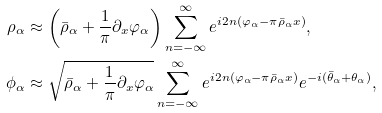<formula> <loc_0><loc_0><loc_500><loc_500>\rho _ { \alpha } & \approx \left ( \bar { \rho } _ { \alpha } + \frac { 1 } { \pi } \partial _ { x } \varphi _ { \alpha } \right ) \sum _ { n = - \infty } ^ { \infty } e ^ { i 2 n ( \varphi _ { \alpha } - \pi \bar { \rho } _ { \alpha } x ) } , \\ \phi _ { \alpha } & \approx \sqrt { \bar { \rho } _ { \alpha } + \frac { 1 } { \pi } \partial _ { x } \varphi _ { \alpha } } \sum _ { n = - \infty } ^ { \infty } e ^ { i 2 n ( \varphi _ { \alpha } - \pi \bar { \rho } _ { \alpha } x ) } e ^ { - i ( { \bar { \theta } } _ { \alpha } + \theta _ { \alpha } ) } ,</formula> 